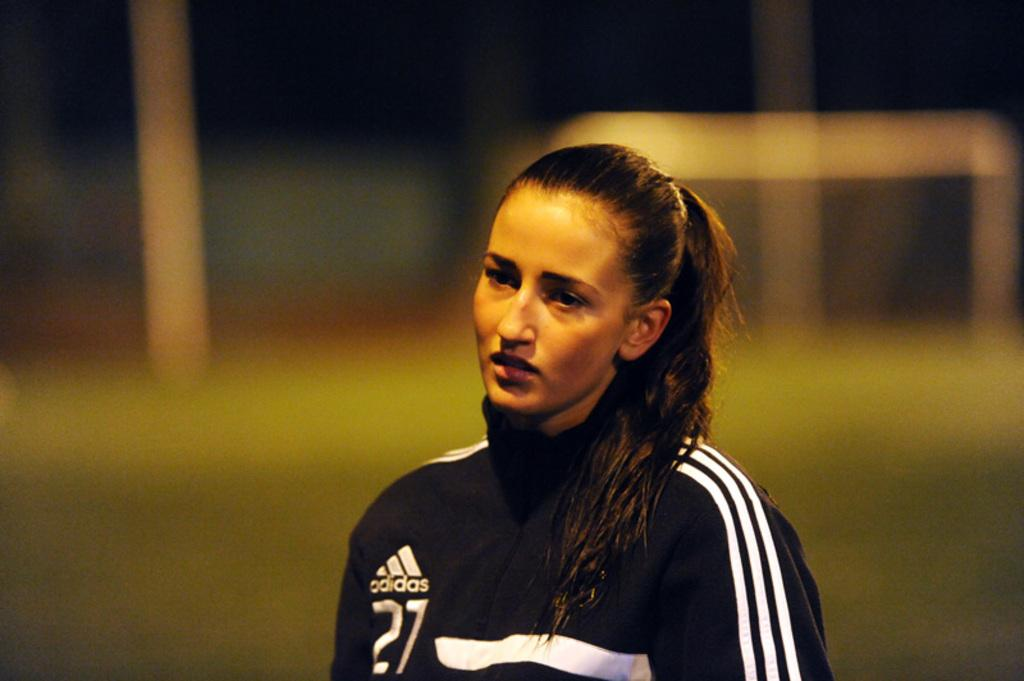<image>
Describe the image concisely. A woman has on a warm-up suit made by adidas. 